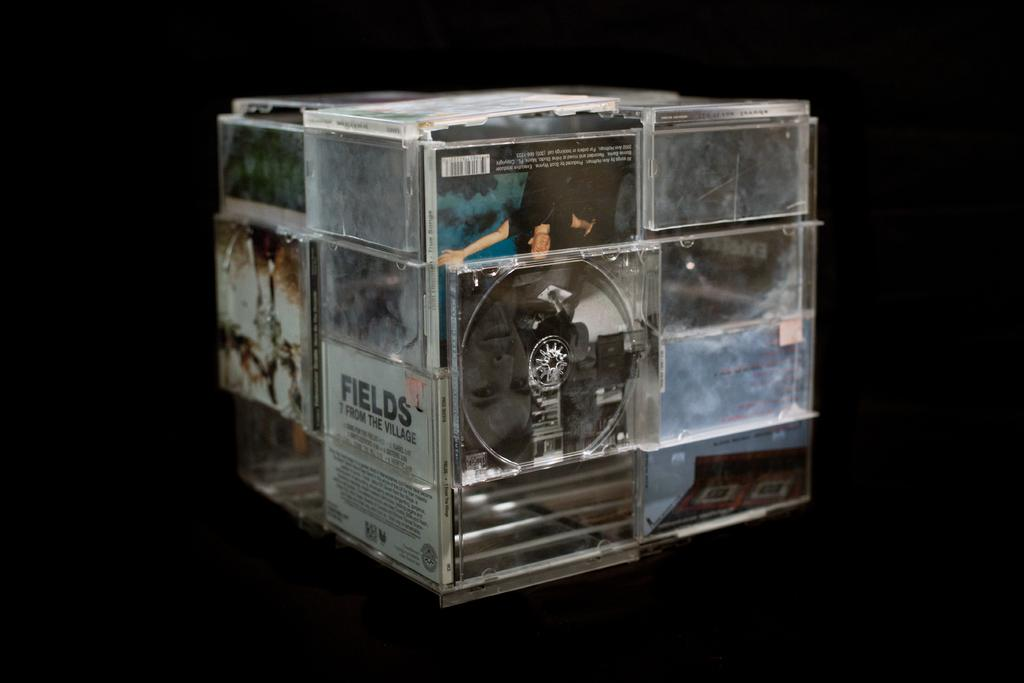<image>
Summarize the visual content of the image. A cube of CD's includes one labeled "FIELDS". 